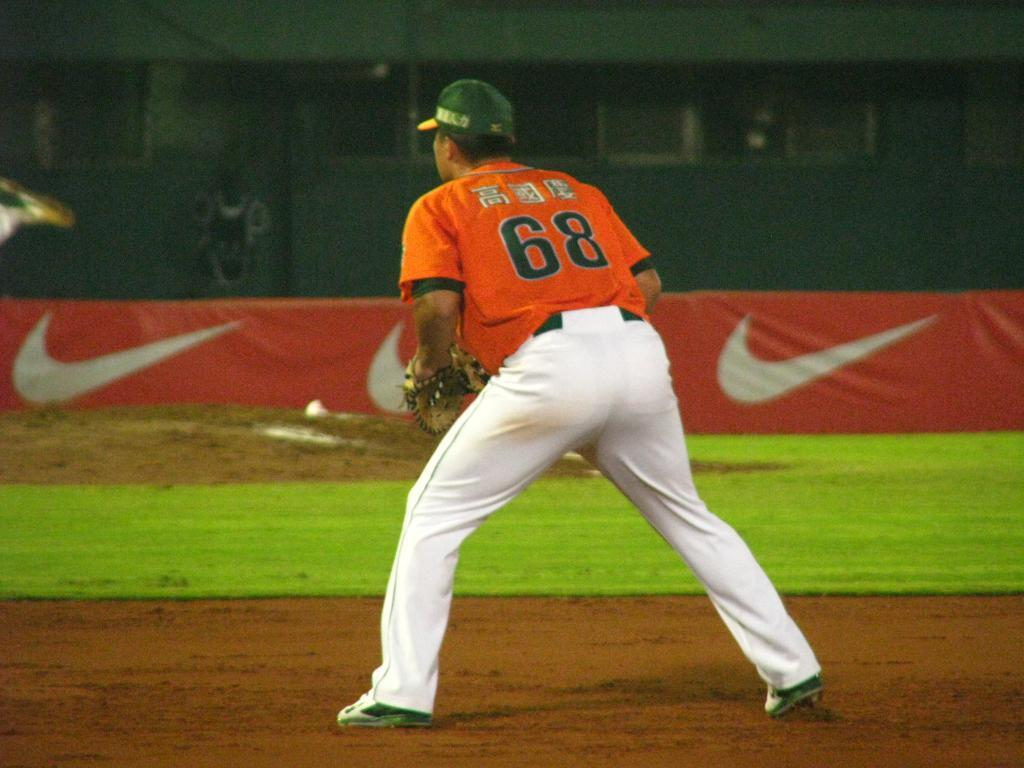<image>
Offer a succinct explanation of the picture presented. A man in a number 68 jersey with Japanese letters on the back stands on a baseball field. 